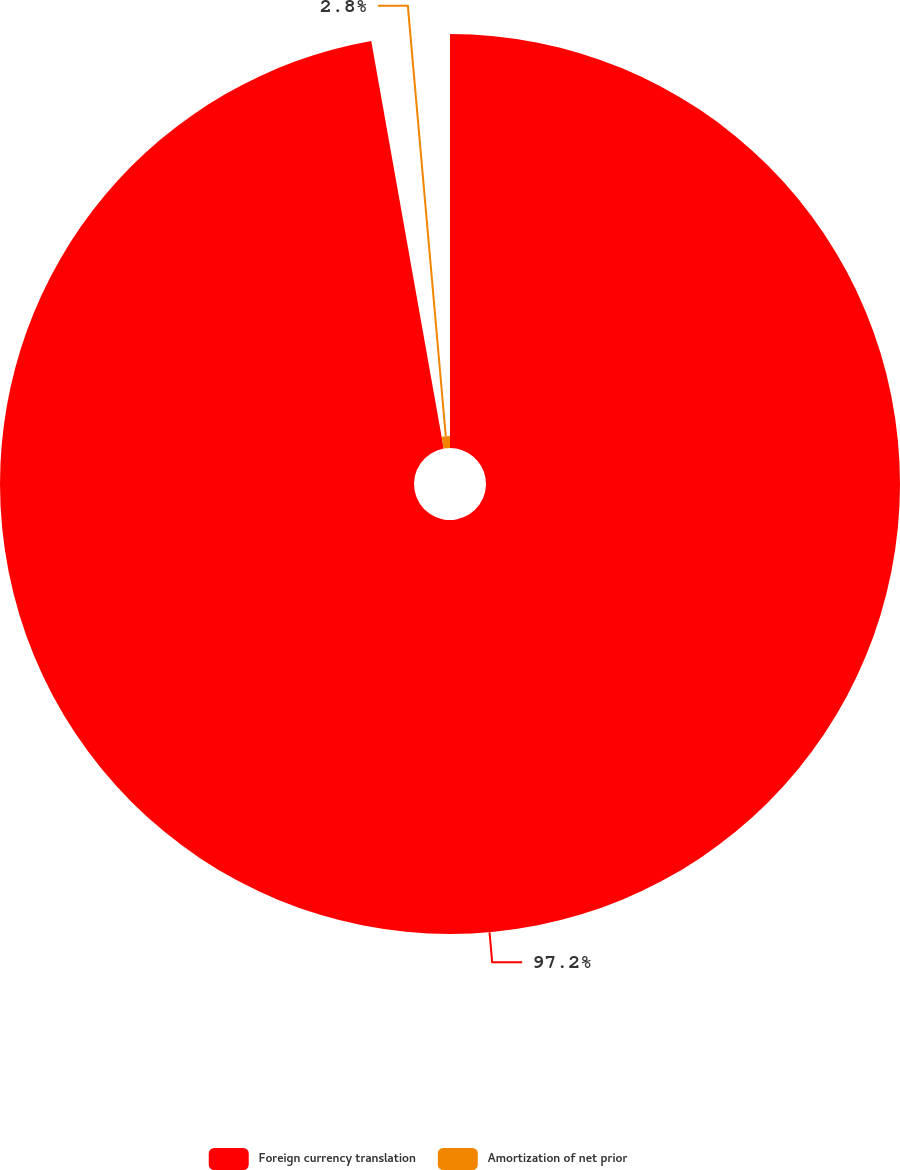Convert chart. <chart><loc_0><loc_0><loc_500><loc_500><pie_chart><fcel>Foreign currency translation<fcel>Amortization of net prior<nl><fcel>97.2%<fcel>2.8%<nl></chart> 